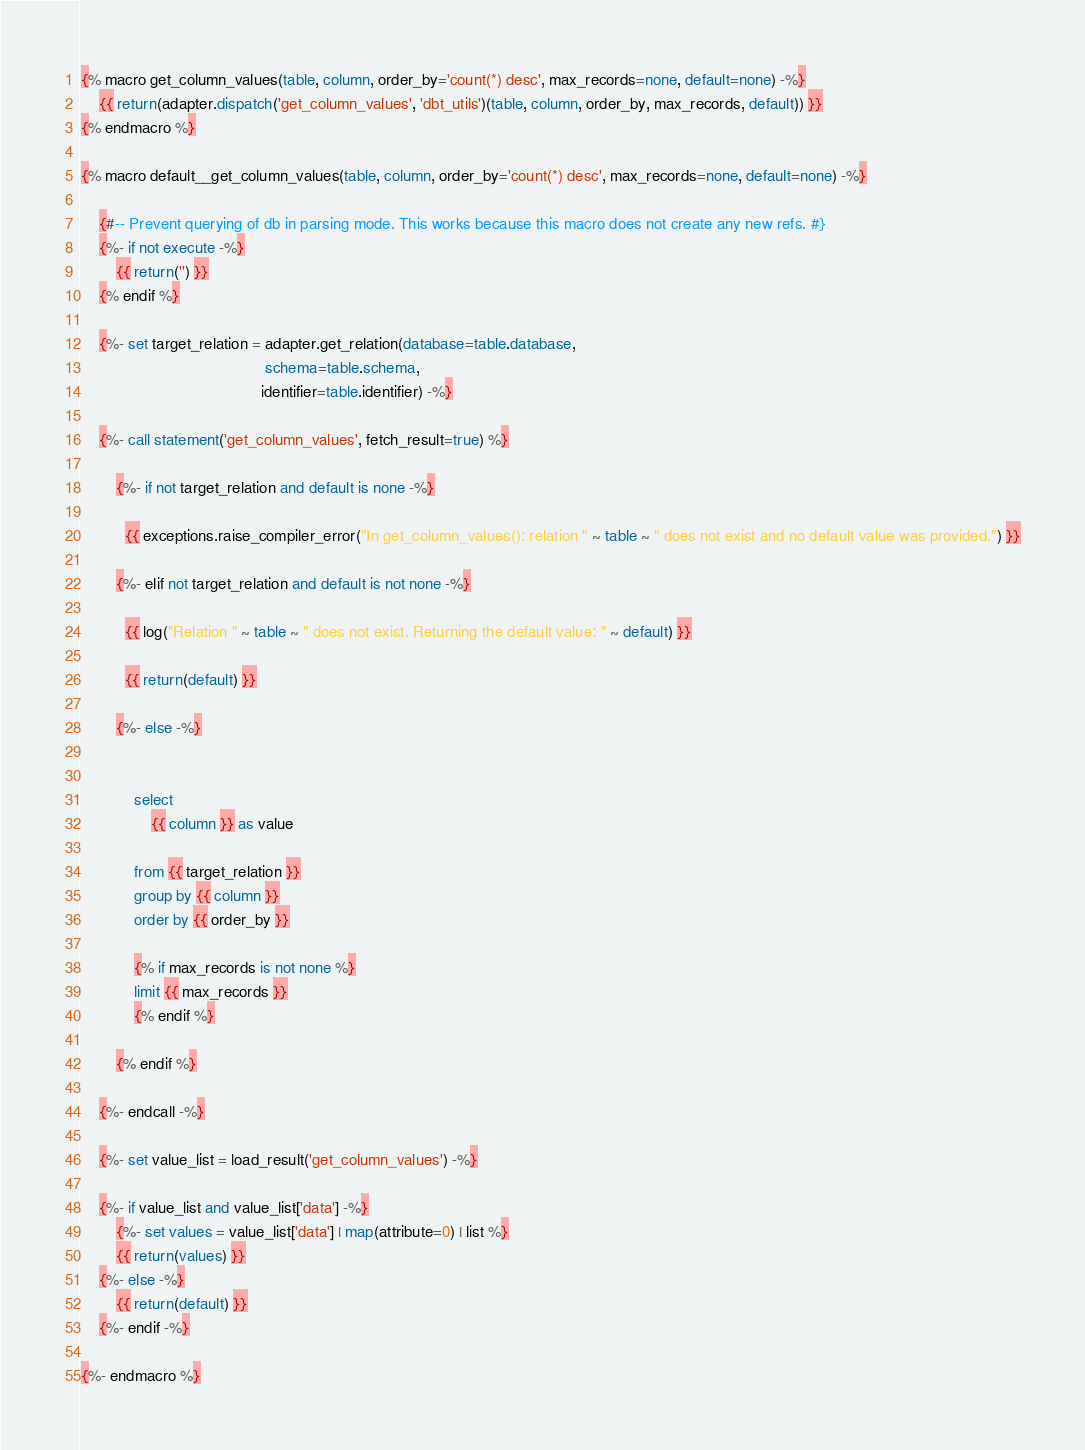Convert code to text. <code><loc_0><loc_0><loc_500><loc_500><_SQL_>{% macro get_column_values(table, column, order_by='count(*) desc', max_records=none, default=none) -%}
    {{ return(adapter.dispatch('get_column_values', 'dbt_utils')(table, column, order_by, max_records, default)) }}
{% endmacro %}

{% macro default__get_column_values(table, column, order_by='count(*) desc', max_records=none, default=none) -%}

    {#-- Prevent querying of db in parsing mode. This works because this macro does not create any new refs. #}
    {%- if not execute -%}
        {{ return('') }}
    {% endif %}

    {%- set target_relation = adapter.get_relation(database=table.database,
                                          schema=table.schema,
                                         identifier=table.identifier) -%}

    {%- call statement('get_column_values', fetch_result=true) %}

        {%- if not target_relation and default is none -%}

          {{ exceptions.raise_compiler_error("In get_column_values(): relation " ~ table ~ " does not exist and no default value was provided.") }}

        {%- elif not target_relation and default is not none -%}

          {{ log("Relation " ~ table ~ " does not exist. Returning the default value: " ~ default) }}

          {{ return(default) }}

        {%- else -%}


            select
                {{ column }} as value

            from {{ target_relation }}
            group by {{ column }}
            order by {{ order_by }}

            {% if max_records is not none %}
            limit {{ max_records }}
            {% endif %}

        {% endif %}

    {%- endcall -%}

    {%- set value_list = load_result('get_column_values') -%}

    {%- if value_list and value_list['data'] -%}
        {%- set values = value_list['data'] | map(attribute=0) | list %}
        {{ return(values) }}
    {%- else -%}
        {{ return(default) }}
    {%- endif -%}

{%- endmacro %}
</code> 